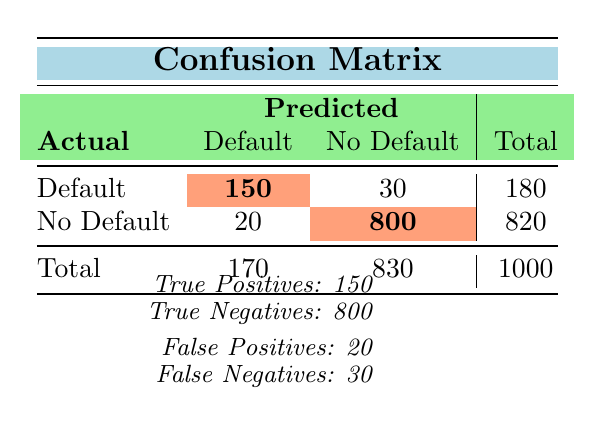What is the total number of actual defaults? By looking at the "Actual" row for "Default," the value is 180. This indicates the total number of loans that actually defaulted.
Answer: 180 What is the number of true negatives? The true negatives are found in the "No Default" column under the "No Default" row, which is 800. This represents the loans that were predicted not to default and indeed did not.
Answer: 800 What is the total number of predicted defaults? To find the total predicted defaults, sum the values in the "Predicted" column for both rows: 150 (True Positives) + 30 (False Negatives) = 180.
Answer: 180 How many loans were falsely predicted to default? This is represented by the "False Positives," which is the value of 20 in the "No Default" row under the "Default" column. This indicates the loans that were predicted to default but actually did not.
Answer: 20 What is the proportion of true positives to total actual defaults? True Positives are 150, and total actual defaults are 180. The proportion can be calculated as 150 / 180, which simplifies to approximately 0.833 or 83.3%.
Answer: 83.3% Is the number of false negatives greater than the number of false positives? The number of false negatives is 30 and the number of false positives is 20. Since 30 is greater than 20, the statement is true.
Answer: Yes What is the sum of true positives and false positives? True Positives are 150 and False Positives are 20. When you add these two values, 150 + 20 equals 170.
Answer: 170 How many loans had no default predicted correctly? This value is found in the "No Default" row under the "No Default" column, which is 800. This represents the loans that were predicted correctly as not defaulting.
Answer: 800 What percentage of predicted defaults turned out to be actual defaults? Predicted defaults total 180 (150 True Positives + 30 False Negatives). Of those, 150 were true positives, so the percentage is (150 / 180) * 100, approximately 83.3%.
Answer: 83.3% 